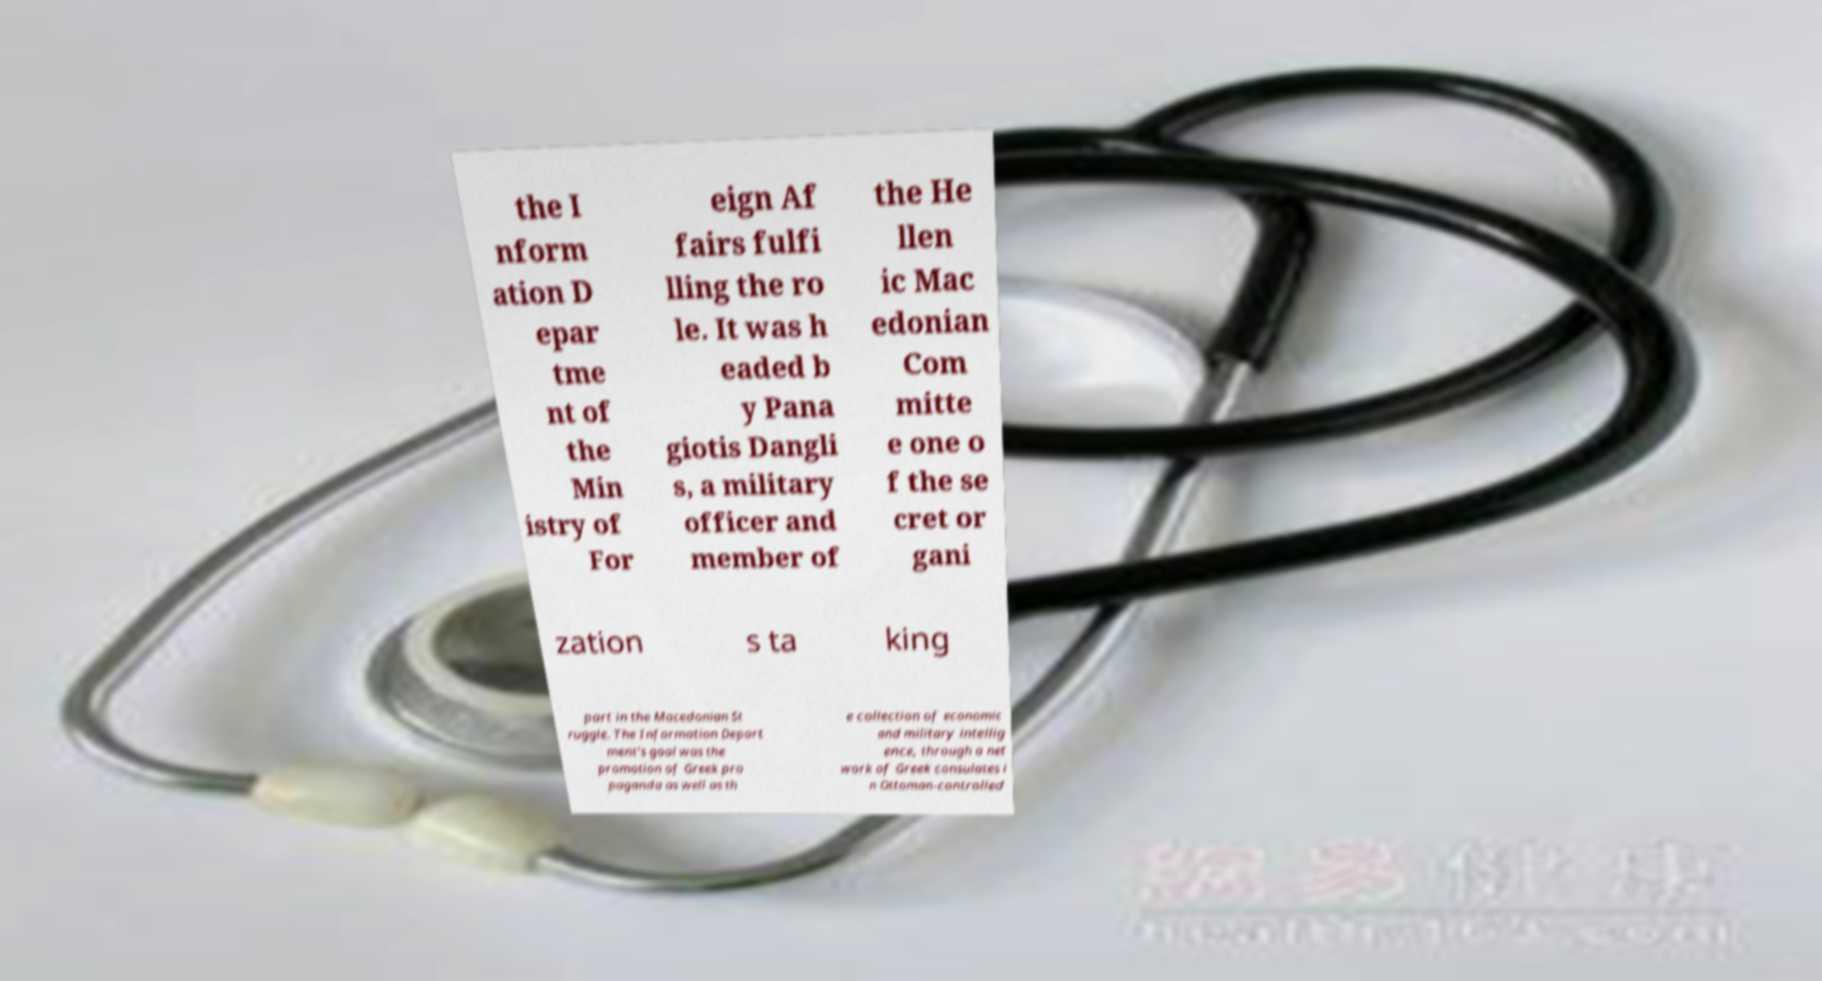Can you accurately transcribe the text from the provided image for me? the I nform ation D epar tme nt of the Min istry of For eign Af fairs fulfi lling the ro le. It was h eaded b y Pana giotis Dangli s, a military officer and member of the He llen ic Mac edonian Com mitte e one o f the se cret or gani zation s ta king part in the Macedonian St ruggle. The Information Depart ment's goal was the promotion of Greek pro paganda as well as th e collection of economic and military intellig ence, through a net work of Greek consulates i n Ottoman-controlled 